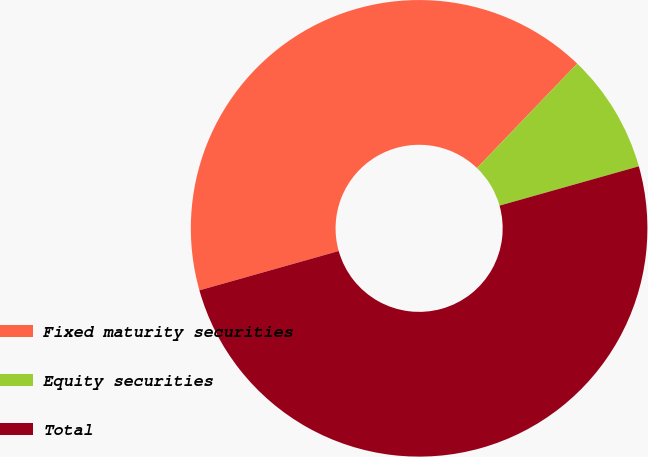Convert chart to OTSL. <chart><loc_0><loc_0><loc_500><loc_500><pie_chart><fcel>Fixed maturity securities<fcel>Equity securities<fcel>Total<nl><fcel>41.55%<fcel>8.45%<fcel>50.0%<nl></chart> 